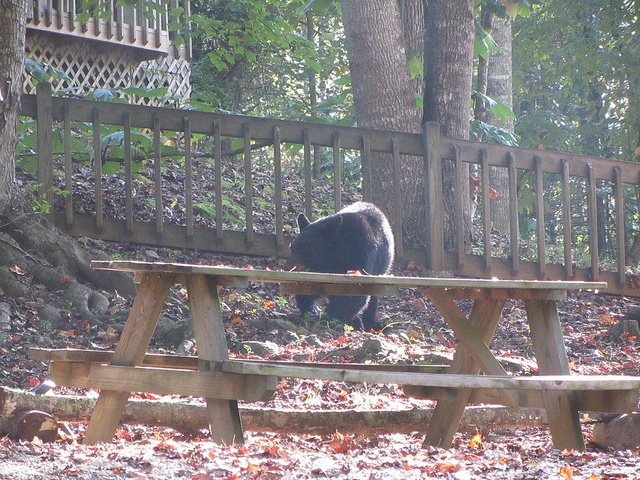Describe the objects in this image and their specific colors. I can see bench in gray, darkgray, and lightgray tones and bear in gray, darkblue, white, and darkgray tones in this image. 